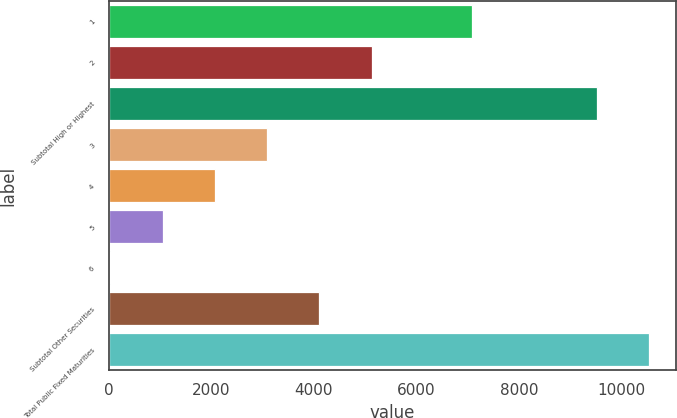Convert chart. <chart><loc_0><loc_0><loc_500><loc_500><bar_chart><fcel>1<fcel>2<fcel>Subtotal High or Highest<fcel>3<fcel>4<fcel>5<fcel>6<fcel>Subtotal Other Securities<fcel>Total Public Fixed Maturities<nl><fcel>7088<fcel>5128.5<fcel>9525<fcel>3087.9<fcel>2067.6<fcel>1047.3<fcel>27<fcel>4108.2<fcel>10545.3<nl></chart> 